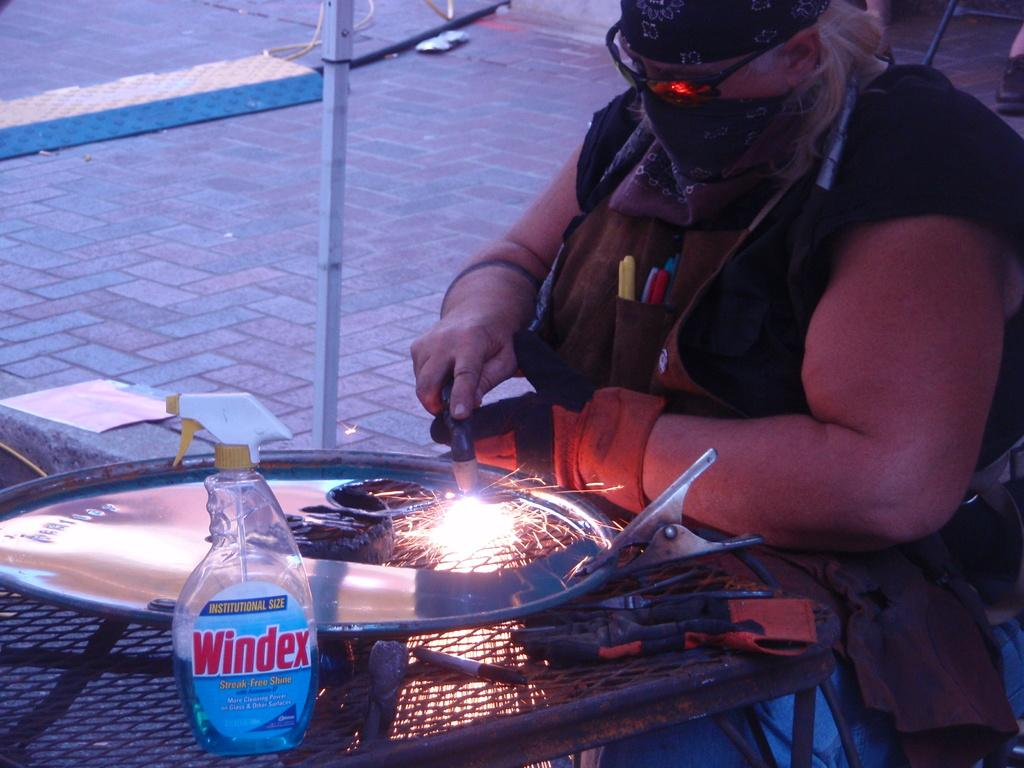What is the person in the image doing? The person is fixing a steel plate. What objects can be seen in the image besides the person and the steel plate? There is a clip, a bottle, and a steel rod in the image. What type of quiver is the person using to hold the steel plate in the image? There is no quiver present in the image; the person is using their hands to fix the steel plate. 